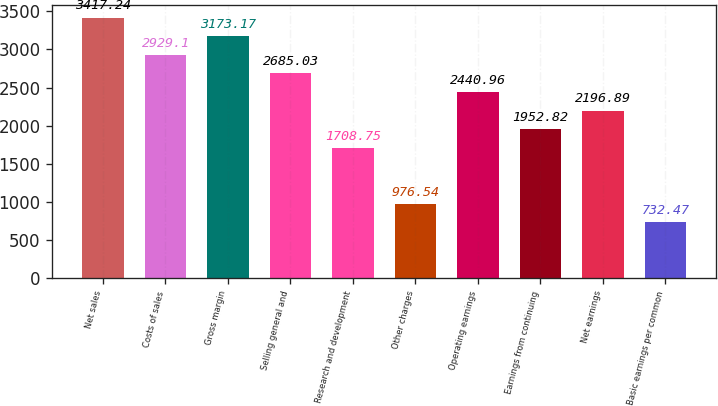Convert chart to OTSL. <chart><loc_0><loc_0><loc_500><loc_500><bar_chart><fcel>Net sales<fcel>Costs of sales<fcel>Gross margin<fcel>Selling general and<fcel>Research and development<fcel>Other charges<fcel>Operating earnings<fcel>Earnings from continuing<fcel>Net earnings<fcel>Basic earnings per common<nl><fcel>3417.24<fcel>2929.1<fcel>3173.17<fcel>2685.03<fcel>1708.75<fcel>976.54<fcel>2440.96<fcel>1952.82<fcel>2196.89<fcel>732.47<nl></chart> 